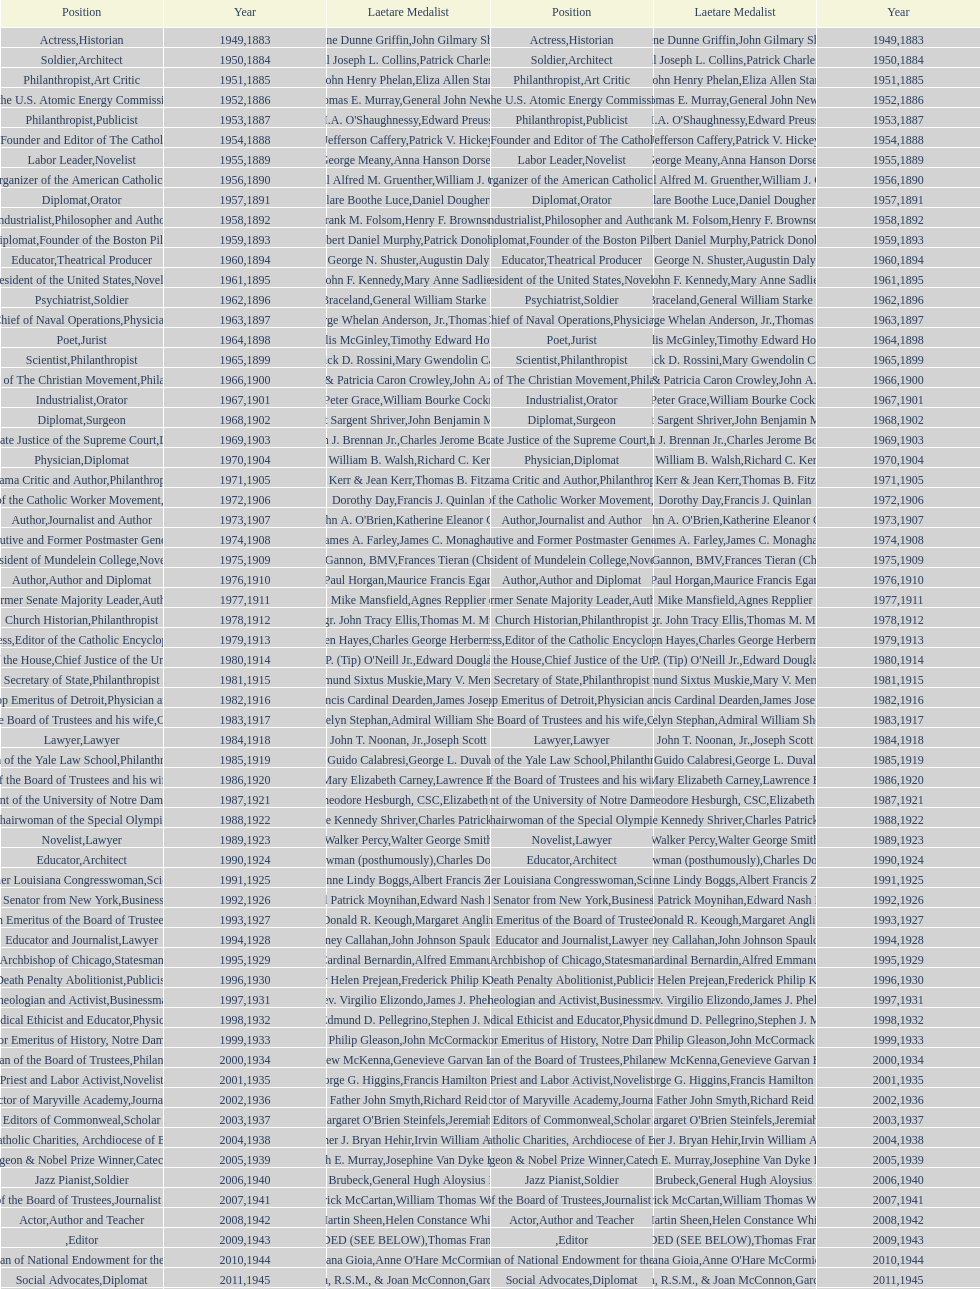Who won the medal after thomas e. murray in 1952? I.A. O'Shaughnessy. 